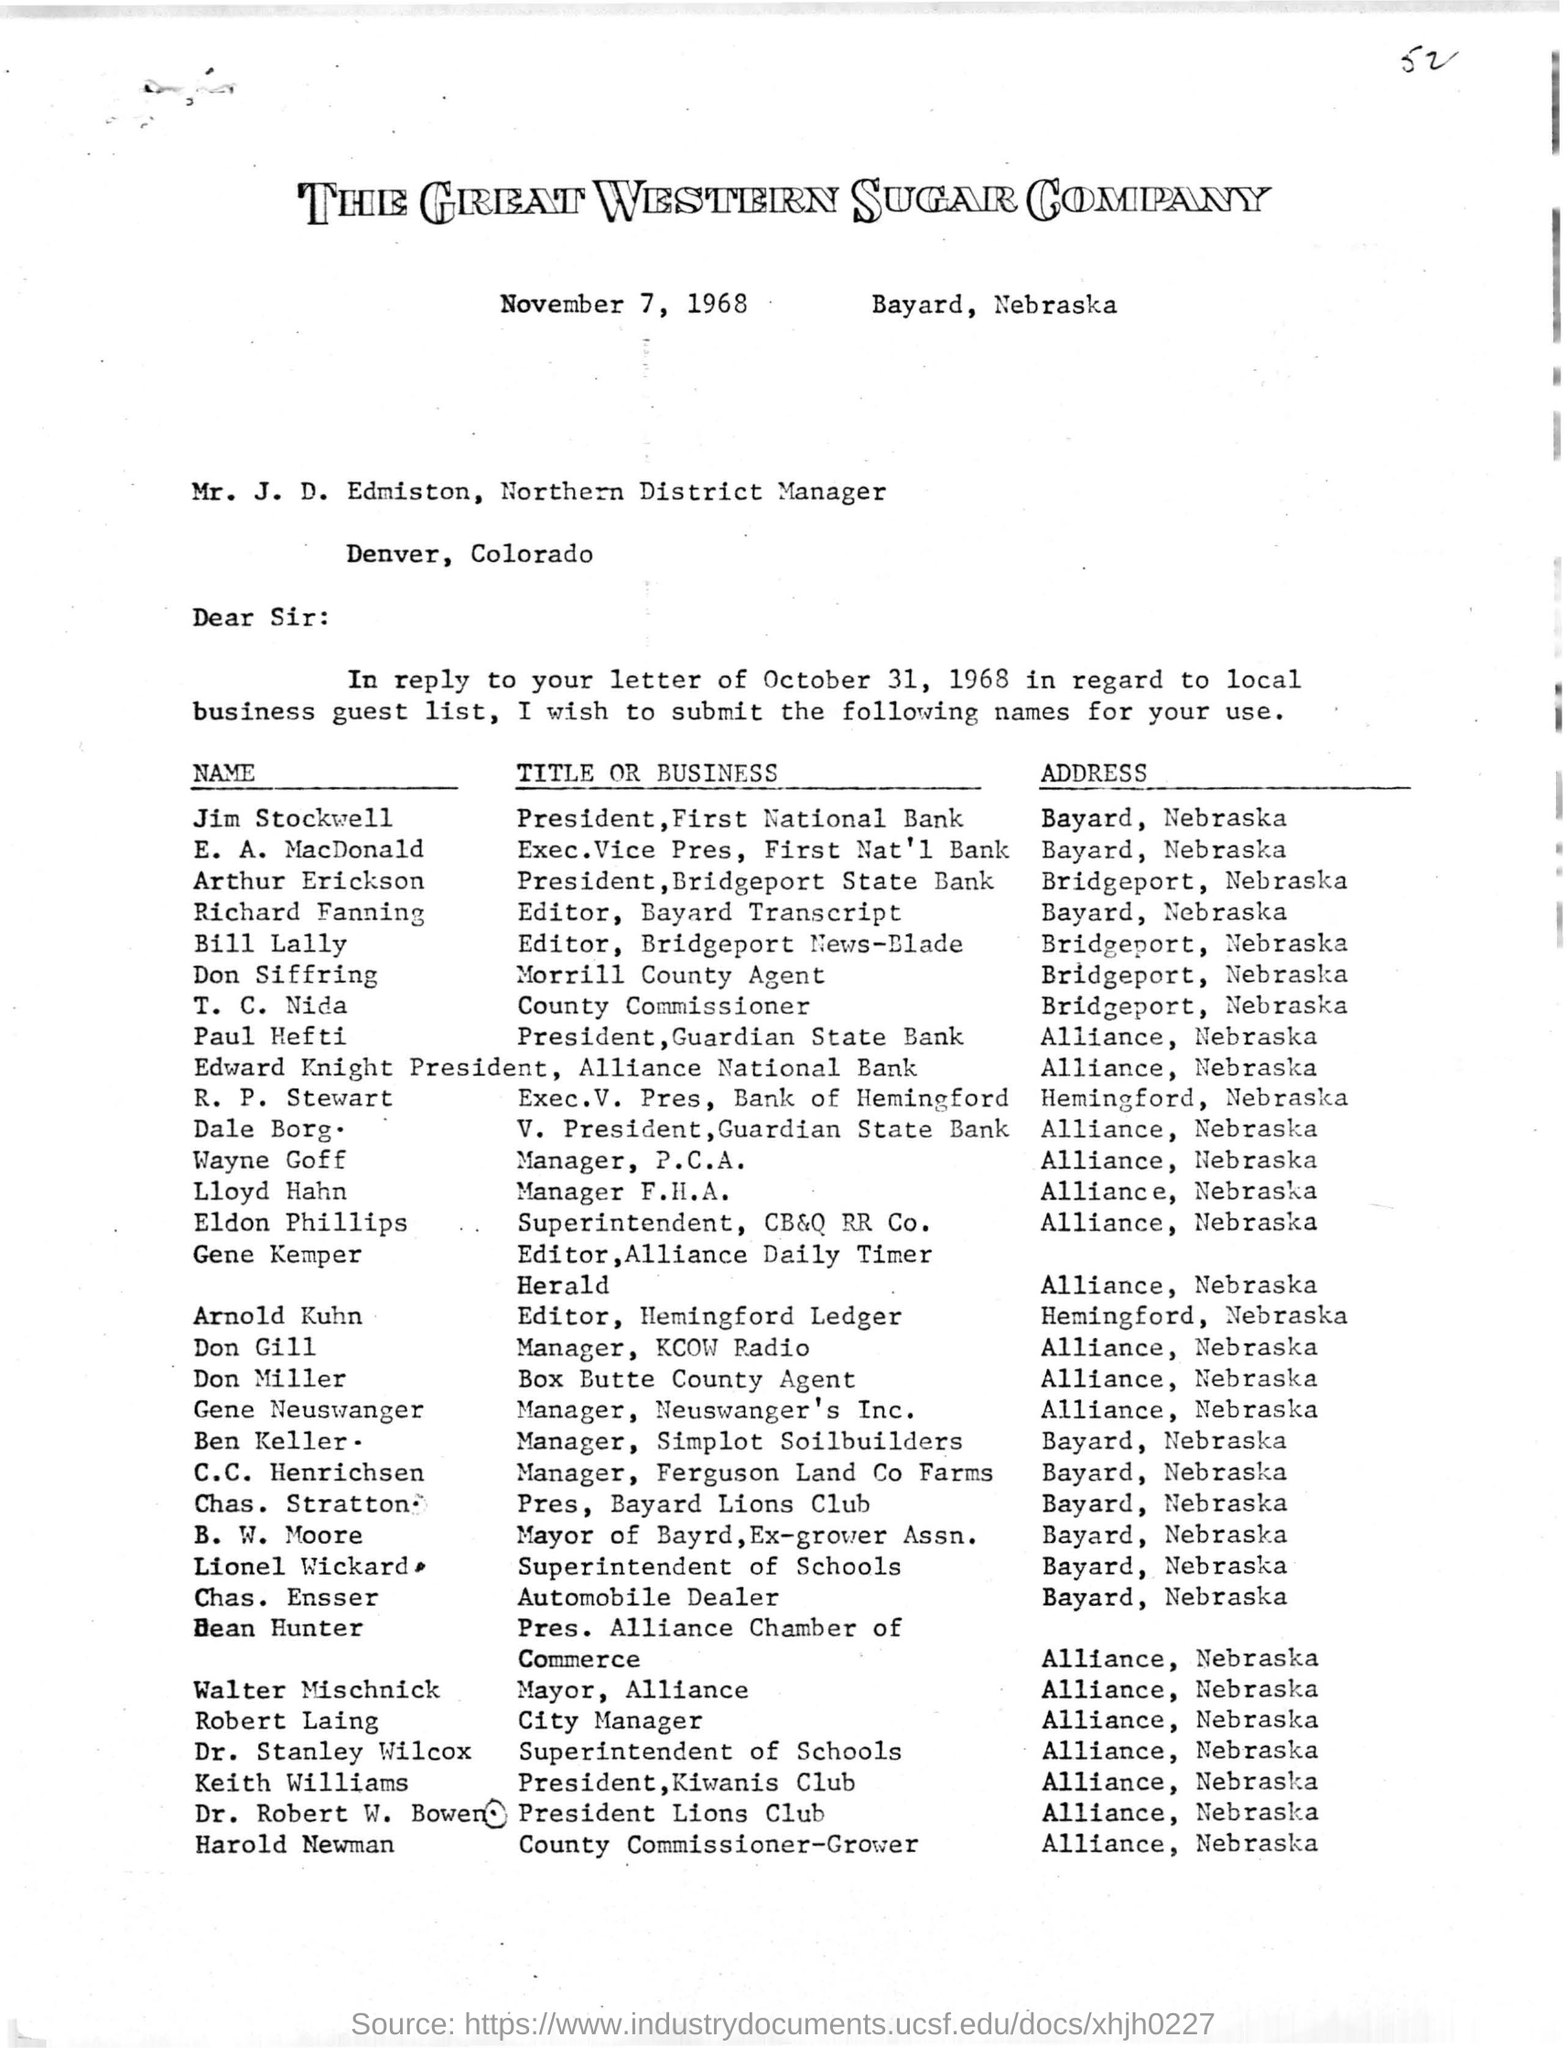Who is the President of First National Bank
Your response must be concise. Jim Stockwell. What is the title of Don Siffring?
Provide a short and direct response. Morrill County Agent. Where is Kiwanis Club?
Provide a short and direct response. Alliance, Nebraska. What is the date of the letter?
Offer a terse response. November 7, 1968. 